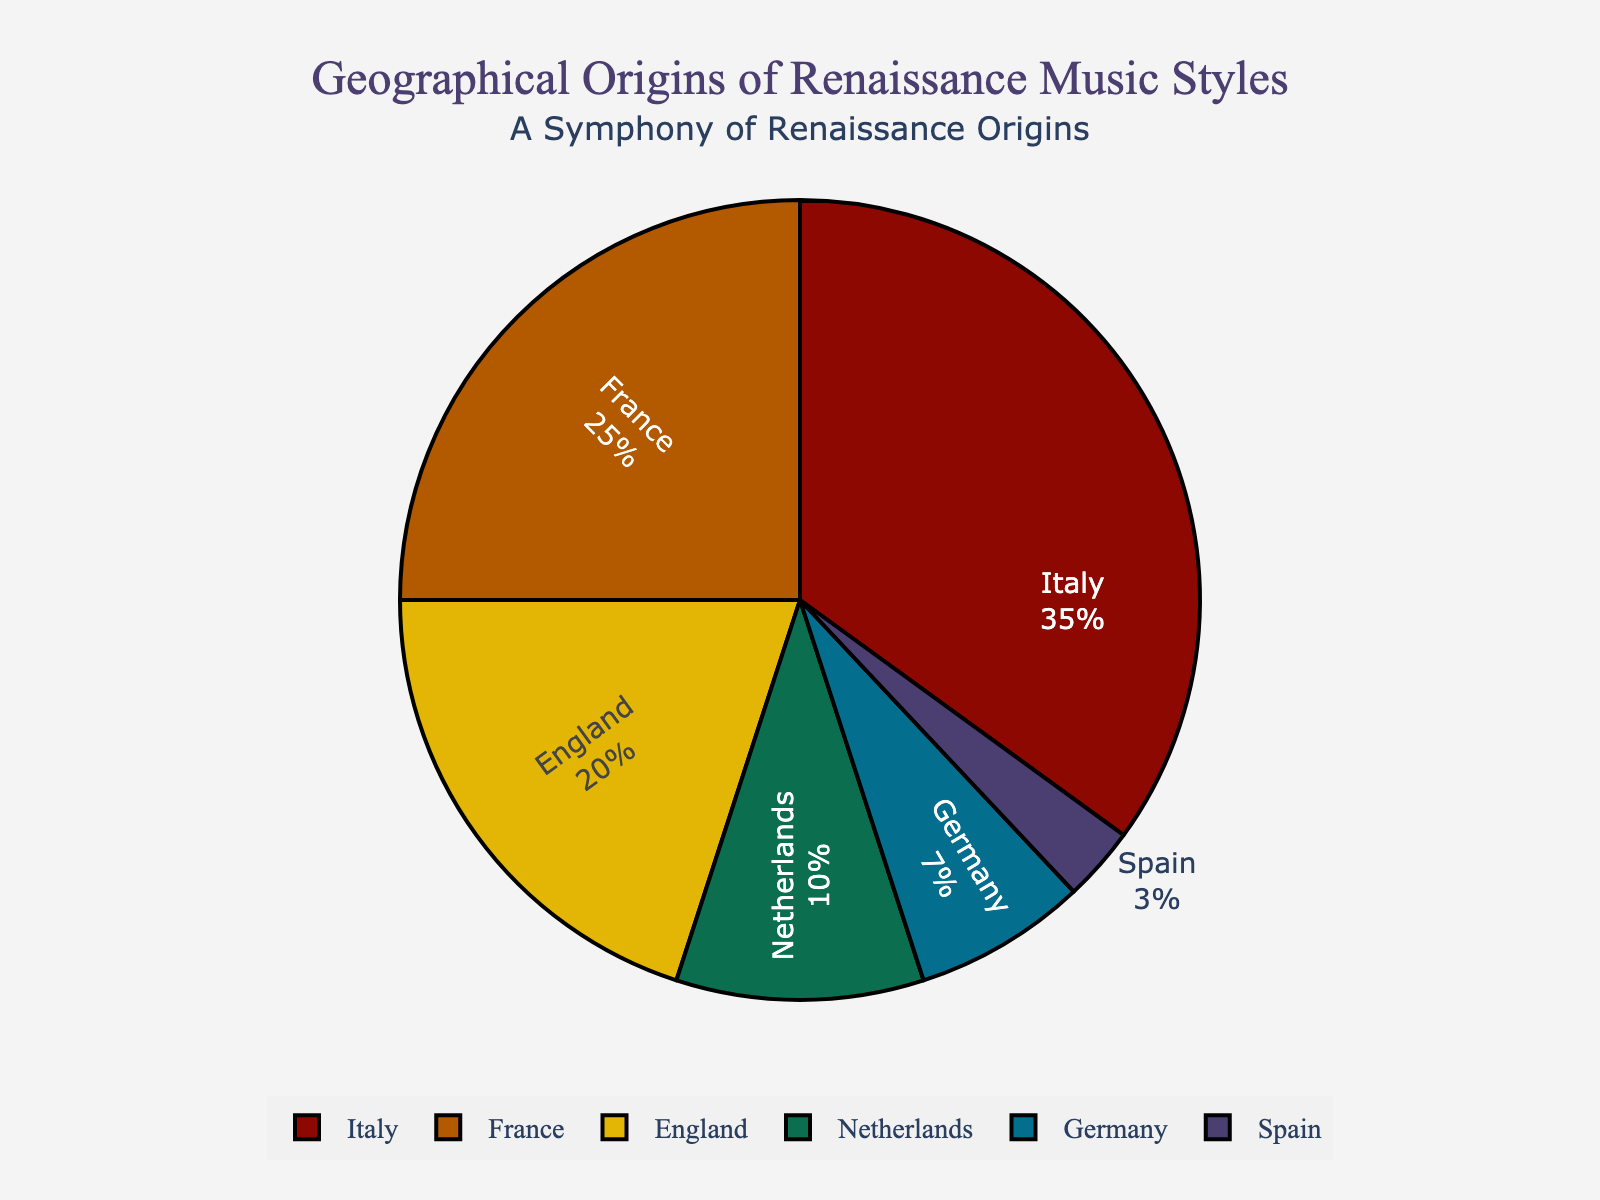What region has the highest percentage of Renaissance music styles? By examining the pie chart, we can see that Italy has the largest slice of the pie, marked with the highest percentage.
Answer: Italy Which two regions combined make up more than half of the origins of Renaissance music styles? The regions Italy and France have the highest percentages. Italy contributes 35% and France contributes 25%. Together, their combined percentage is 35% + 25% = 60%, which is more than half of the total.
Answer: Italy and France How much more does Italy contribute to Renaissance music styles compared to Spain? Italy contributes 35% while Spain contributes 3%. The difference is 35% - 3% = 32%.
Answer: 32% What is the sum of the contributions from England and the Netherlands? England contributes 20% and the Netherlands contributes 10%. Their combined contribution sum is 20% + 10% = 30%.
Answer: 30% Which regions contribute less than 10% each to the origins of Renaissance music styles? By observing the pie chart, Germany and Spain are the regions with percentages less than 10% (Germany at 7% and Spain at 3%).
Answer: Germany and Spain What percentage of Renaissance music styles originate from regions other than Italy? Italy contributes 35%. The total percentage without Italy is 100% - 35% = 65%.
Answer: 65% How does the contribution of France to Renaissance music styles compare to that of the Netherlands? France contributes 25% while the Netherlands contributes 10%. France contributes more than double (25% > 10%).
Answer: More than double Identify the regions represented by the largest and smallest slices, respectively. The largest slice corresponds to Italy with 35%, and the smallest slice corresponds to Spain with 3%.
Answer: Italy and Spain Which color represents England's slice of the pie chart? From the color palette, England's slice is represented by the second color in sequence after Italy and France, which follows the order as per the data input.
Answer: third color in sequence 